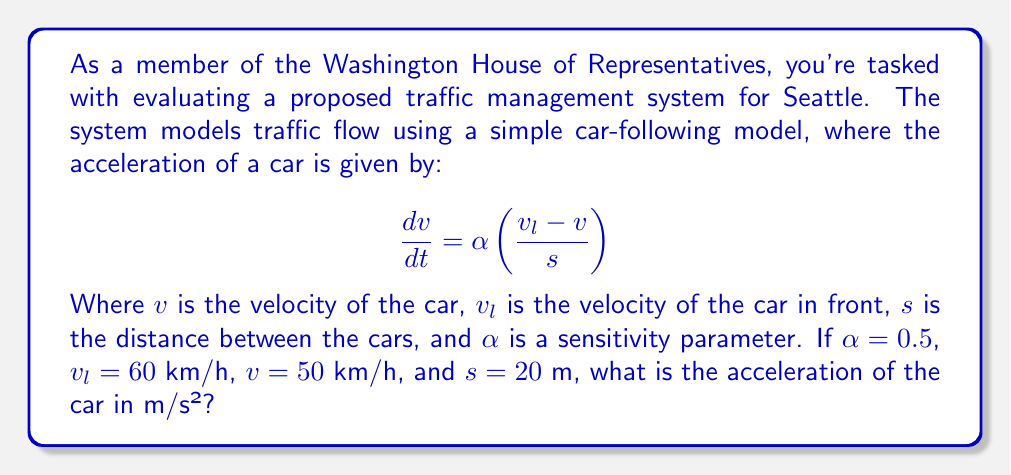Give your solution to this math problem. Let's approach this step-by-step:

1) We're given the equation:

   $$\frac{dv}{dt} = \alpha \left(\frac{v_l - v}{s}\right)$$

2) We need to plug in the values:
   - $\alpha = 0.5$
   - $v_l = 60$ km/h
   - $v = 50$ km/h
   - $s = 20$ m

3) First, we need to convert the velocities to m/s:
   - $v_l = 60$ km/h = $60 * (1000/3600)$ m/s = $16.67$ m/s
   - $v = 50$ km/h = $50 * (1000/3600)$ m/s = $13.89$ m/s

4) Now we can substitute these values into the equation:

   $$\frac{dv}{dt} = 0.5 \left(\frac{16.67 - 13.89}{20}\right)$$

5) Simplify the numerator:

   $$\frac{dv}{dt} = 0.5 \left(\frac{2.78}{20}\right)$$

6) Divide inside the parentheses:

   $$\frac{dv}{dt} = 0.5 (0.139)$$

7) Multiply:

   $$\frac{dv}{dt} = 0.0695$$

8) The result, $0.0695$ m/s², is the acceleration of the car.
Answer: $0.0695$ m/s² 